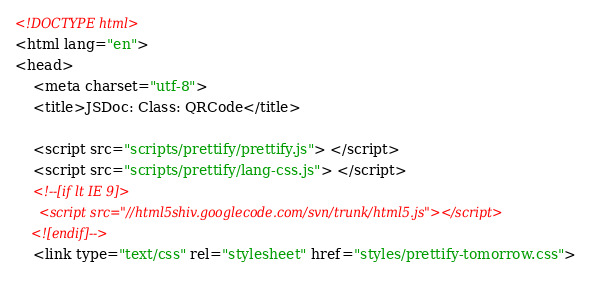Convert code to text. <code><loc_0><loc_0><loc_500><loc_500><_HTML_><!DOCTYPE html>
<html lang="en">
<head>
    <meta charset="utf-8">
    <title>JSDoc: Class: QRCode</title>

    <script src="scripts/prettify/prettify.js"> </script>
    <script src="scripts/prettify/lang-css.js"> </script>
    <!--[if lt IE 9]>
      <script src="//html5shiv.googlecode.com/svn/trunk/html5.js"></script>
    <![endif]-->
    <link type="text/css" rel="stylesheet" href="styles/prettify-tomorrow.css"></code> 